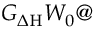<formula> <loc_0><loc_0><loc_500><loc_500>G _ { \Delta H } W _ { 0 }</formula> 